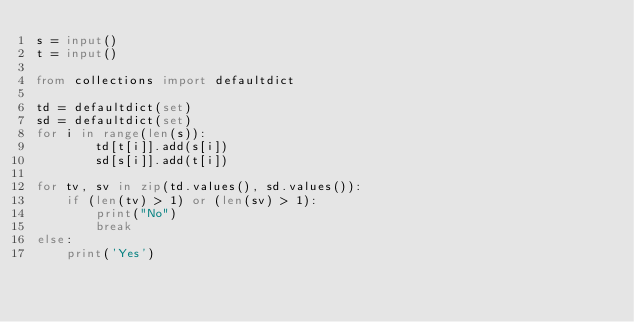<code> <loc_0><loc_0><loc_500><loc_500><_Python_>s = input()
t = input()

from collections import defaultdict

td = defaultdict(set)
sd = defaultdict(set)
for i in range(len(s)):
        td[t[i]].add(s[i])
        sd[s[i]].add(t[i])

for tv, sv in zip(td.values(), sd.values()):
    if (len(tv) > 1) or (len(sv) > 1):
        print("No")
        break
else:
    print('Yes')</code> 